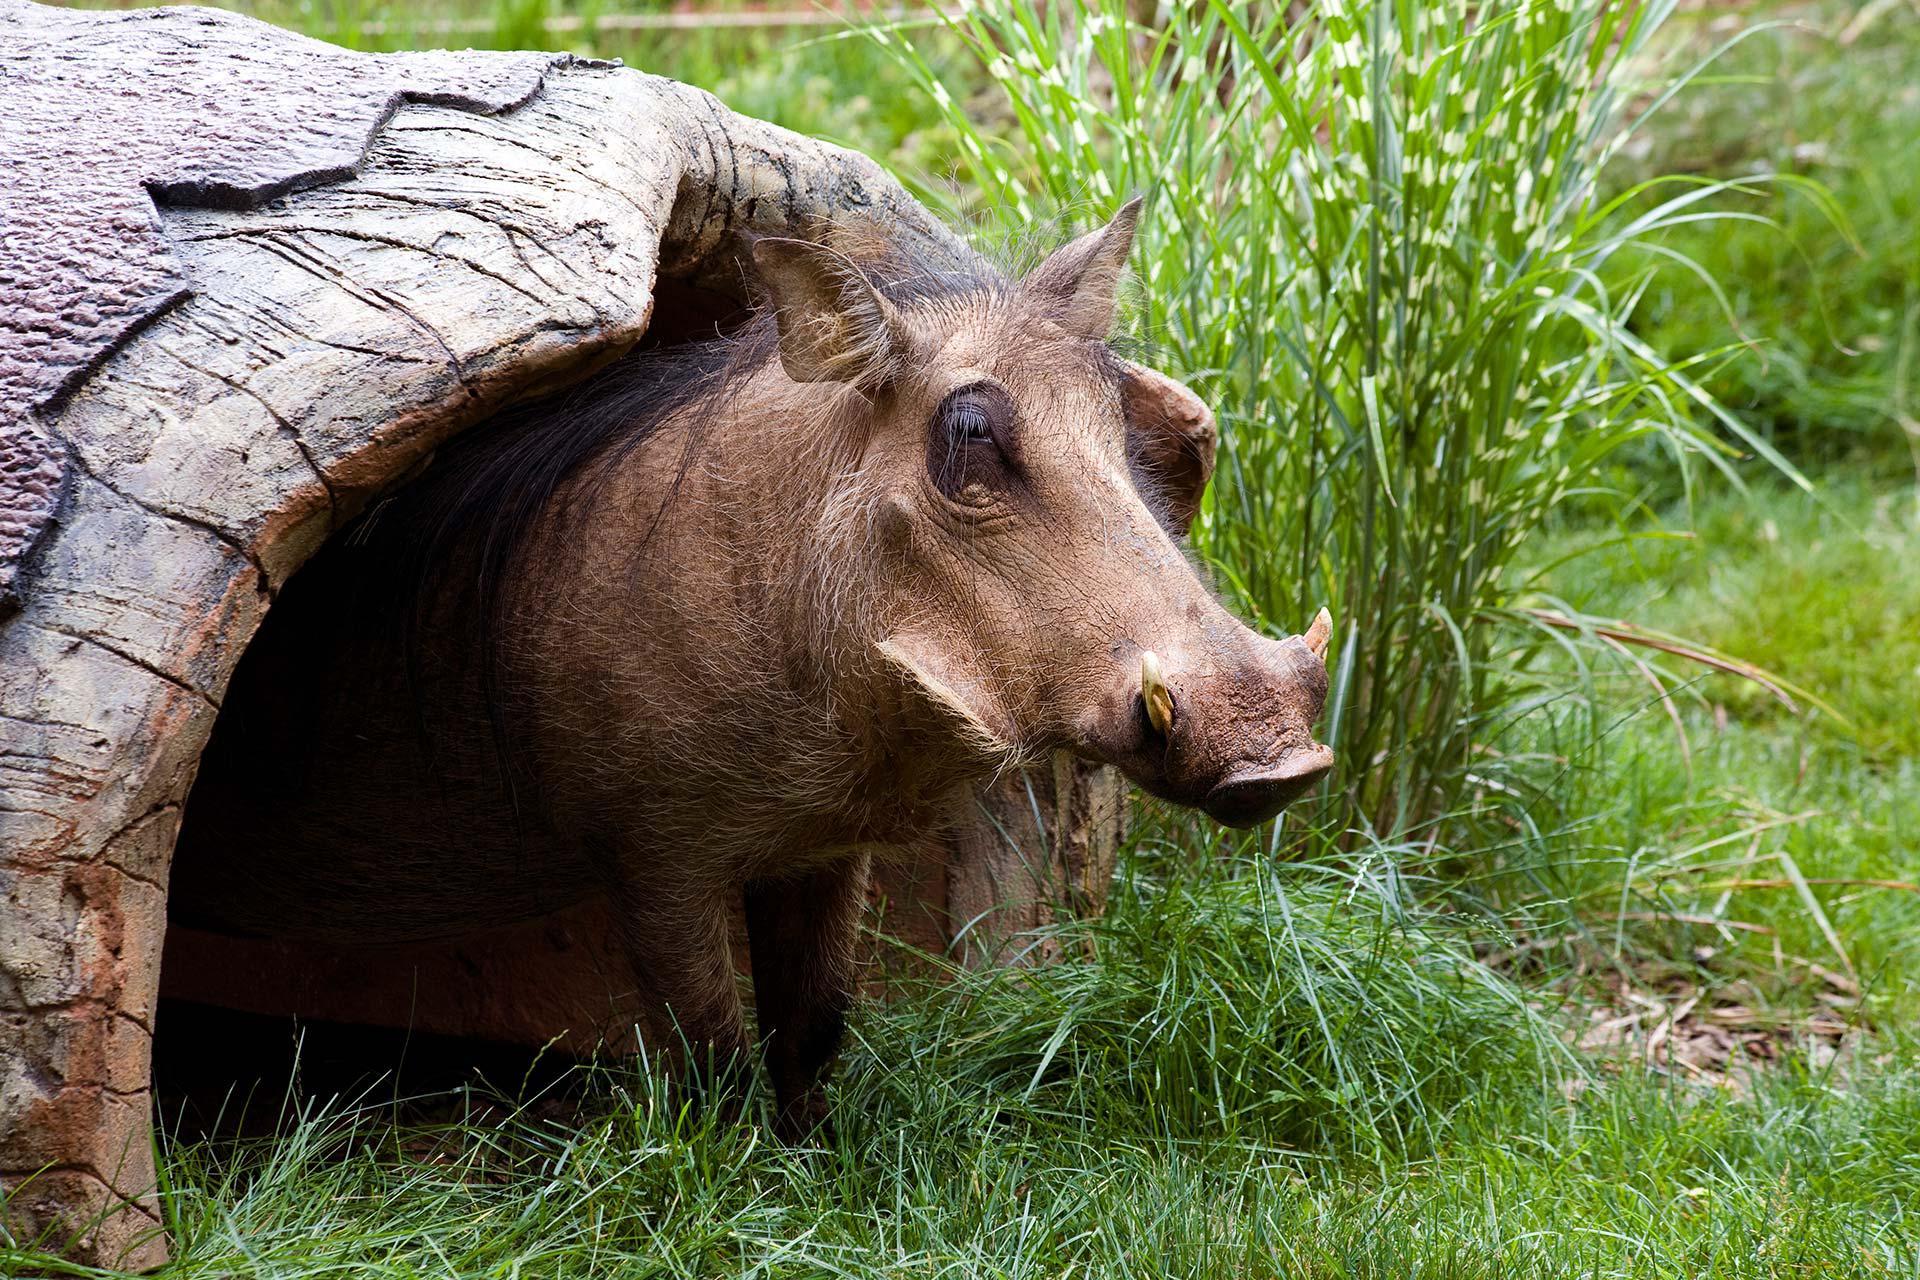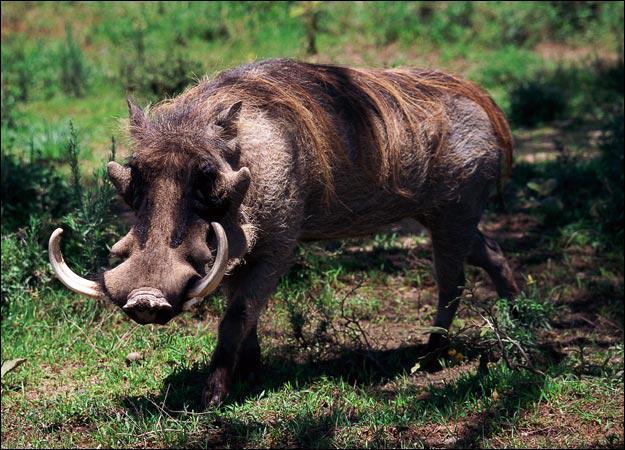The first image is the image on the left, the second image is the image on the right. Given the left and right images, does the statement "The background of one of the images contains much more greenery than it's partner-image." hold true? Answer yes or no. No. 